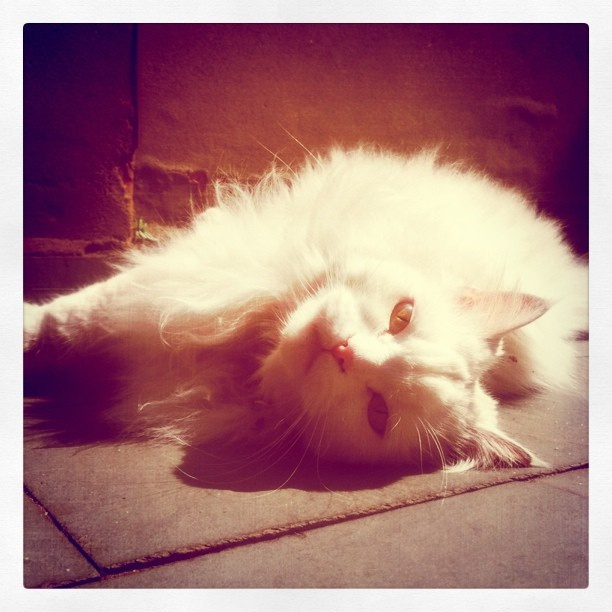Describe the objects in this image and their specific colors. I can see a cat in whitesmoke, lightyellow, tan, purple, and brown tones in this image. 